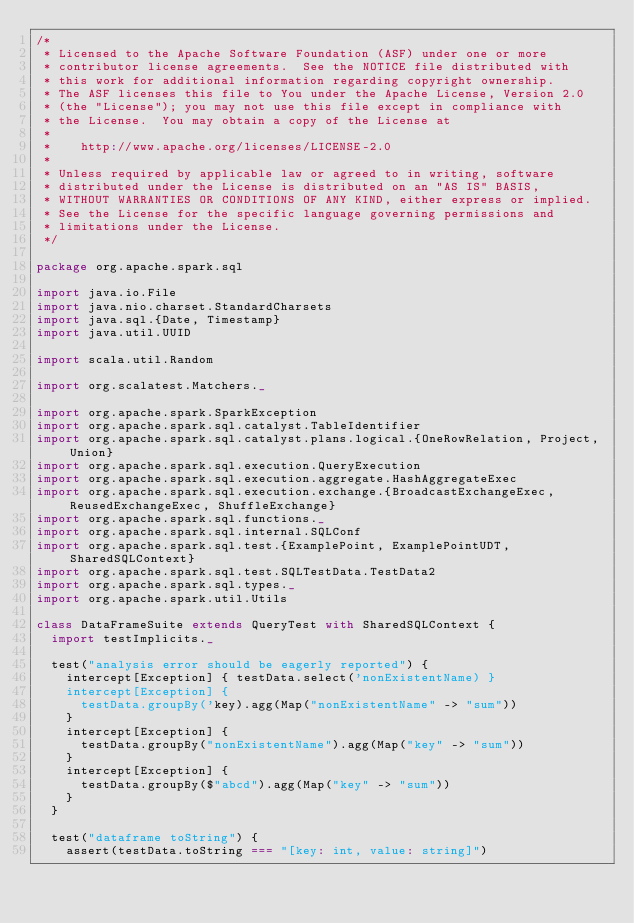<code> <loc_0><loc_0><loc_500><loc_500><_Scala_>/*
 * Licensed to the Apache Software Foundation (ASF) under one or more
 * contributor license agreements.  See the NOTICE file distributed with
 * this work for additional information regarding copyright ownership.
 * The ASF licenses this file to You under the Apache License, Version 2.0
 * (the "License"); you may not use this file except in compliance with
 * the License.  You may obtain a copy of the License at
 *
 *    http://www.apache.org/licenses/LICENSE-2.0
 *
 * Unless required by applicable law or agreed to in writing, software
 * distributed under the License is distributed on an "AS IS" BASIS,
 * WITHOUT WARRANTIES OR CONDITIONS OF ANY KIND, either express or implied.
 * See the License for the specific language governing permissions and
 * limitations under the License.
 */

package org.apache.spark.sql

import java.io.File
import java.nio.charset.StandardCharsets
import java.sql.{Date, Timestamp}
import java.util.UUID

import scala.util.Random

import org.scalatest.Matchers._

import org.apache.spark.SparkException
import org.apache.spark.sql.catalyst.TableIdentifier
import org.apache.spark.sql.catalyst.plans.logical.{OneRowRelation, Project, Union}
import org.apache.spark.sql.execution.QueryExecution
import org.apache.spark.sql.execution.aggregate.HashAggregateExec
import org.apache.spark.sql.execution.exchange.{BroadcastExchangeExec, ReusedExchangeExec, ShuffleExchange}
import org.apache.spark.sql.functions._
import org.apache.spark.sql.internal.SQLConf
import org.apache.spark.sql.test.{ExamplePoint, ExamplePointUDT, SharedSQLContext}
import org.apache.spark.sql.test.SQLTestData.TestData2
import org.apache.spark.sql.types._
import org.apache.spark.util.Utils

class DataFrameSuite extends QueryTest with SharedSQLContext {
  import testImplicits._

  test("analysis error should be eagerly reported") {
    intercept[Exception] { testData.select('nonExistentName) }
    intercept[Exception] {
      testData.groupBy('key).agg(Map("nonExistentName" -> "sum"))
    }
    intercept[Exception] {
      testData.groupBy("nonExistentName").agg(Map("key" -> "sum"))
    }
    intercept[Exception] {
      testData.groupBy($"abcd").agg(Map("key" -> "sum"))
    }
  }

  test("dataframe toString") {
    assert(testData.toString === "[key: int, value: string]")</code> 